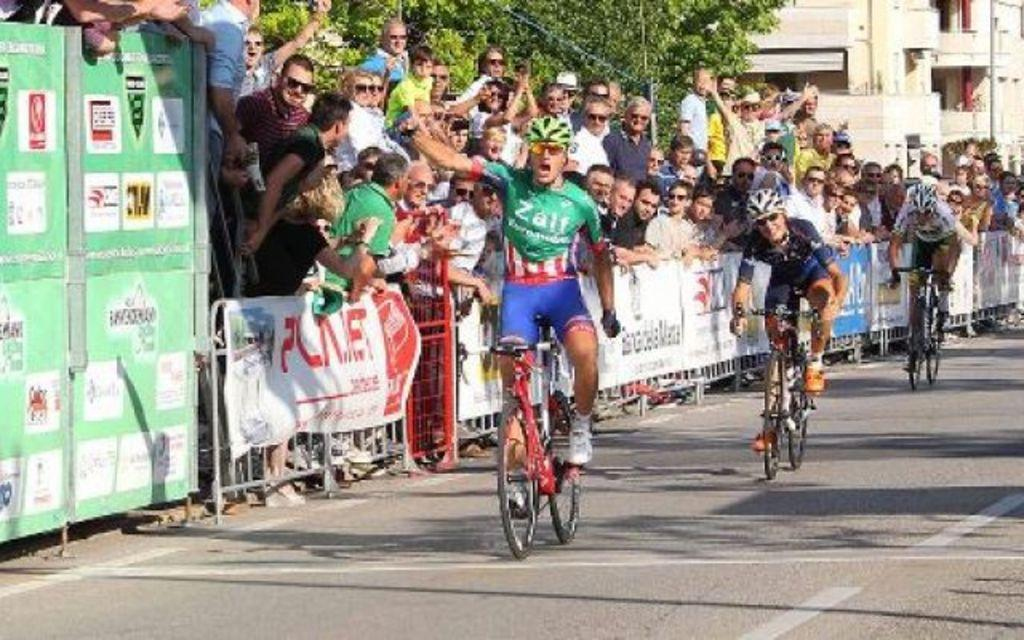Provide a one-sentence caption for the provided image. A group of cyclists on a road with people on the side behind a barrier cheering them on as the man in green wears a cyclist uniform that says Zalf. 